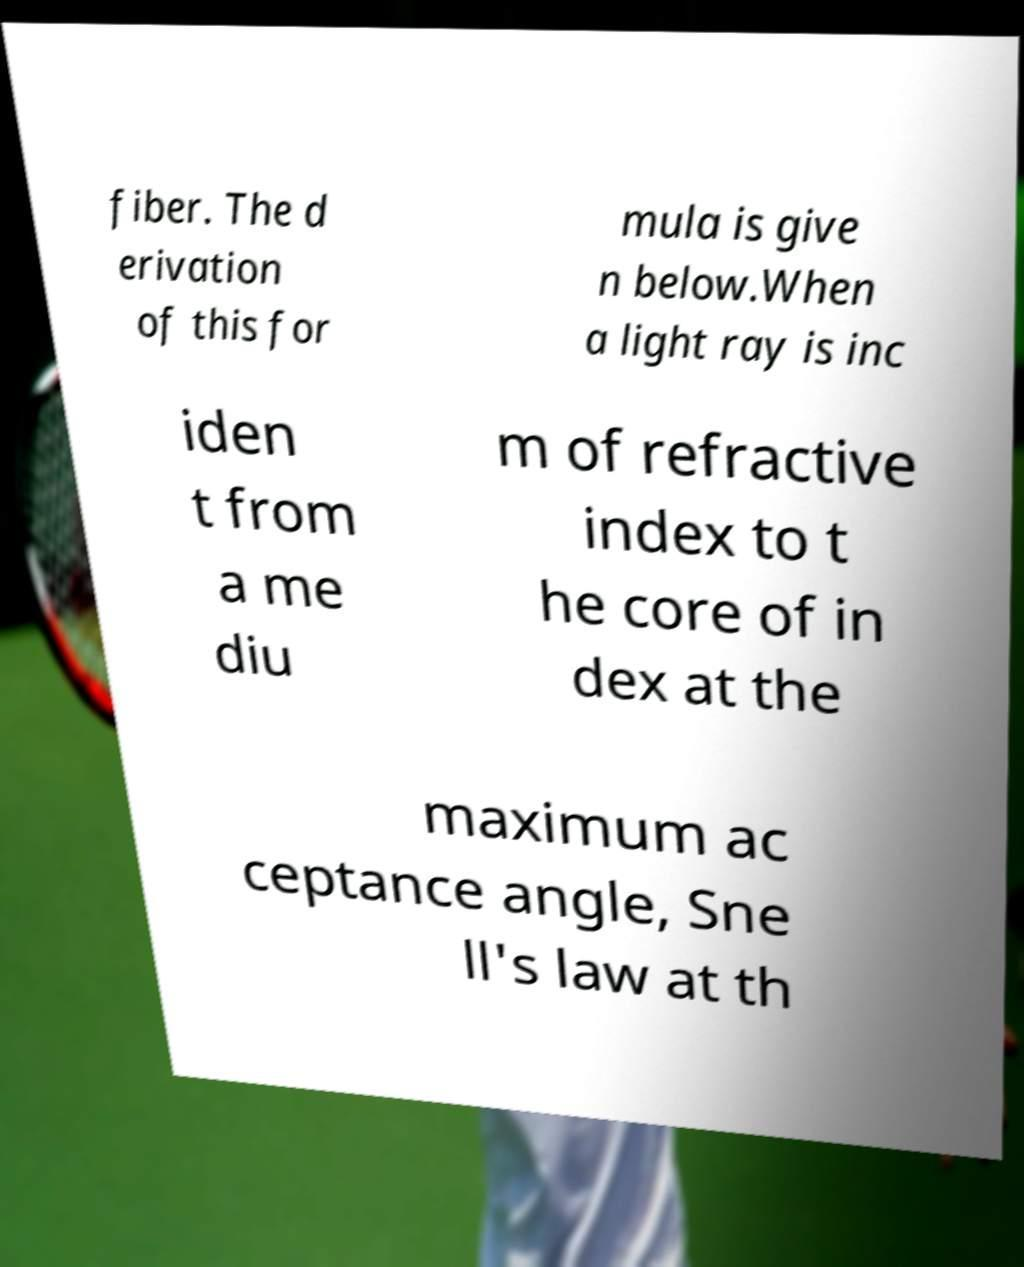Could you assist in decoding the text presented in this image and type it out clearly? fiber. The d erivation of this for mula is give n below.When a light ray is inc iden t from a me diu m of refractive index to t he core of in dex at the maximum ac ceptance angle, Sne ll's law at th 